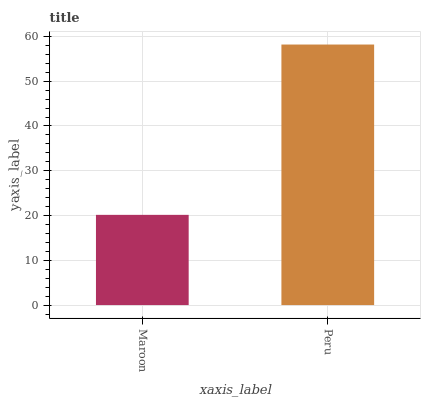Is Maroon the minimum?
Answer yes or no. Yes. Is Peru the maximum?
Answer yes or no. Yes. Is Peru the minimum?
Answer yes or no. No. Is Peru greater than Maroon?
Answer yes or no. Yes. Is Maroon less than Peru?
Answer yes or no. Yes. Is Maroon greater than Peru?
Answer yes or no. No. Is Peru less than Maroon?
Answer yes or no. No. Is Peru the high median?
Answer yes or no. Yes. Is Maroon the low median?
Answer yes or no. Yes. Is Maroon the high median?
Answer yes or no. No. Is Peru the low median?
Answer yes or no. No. 